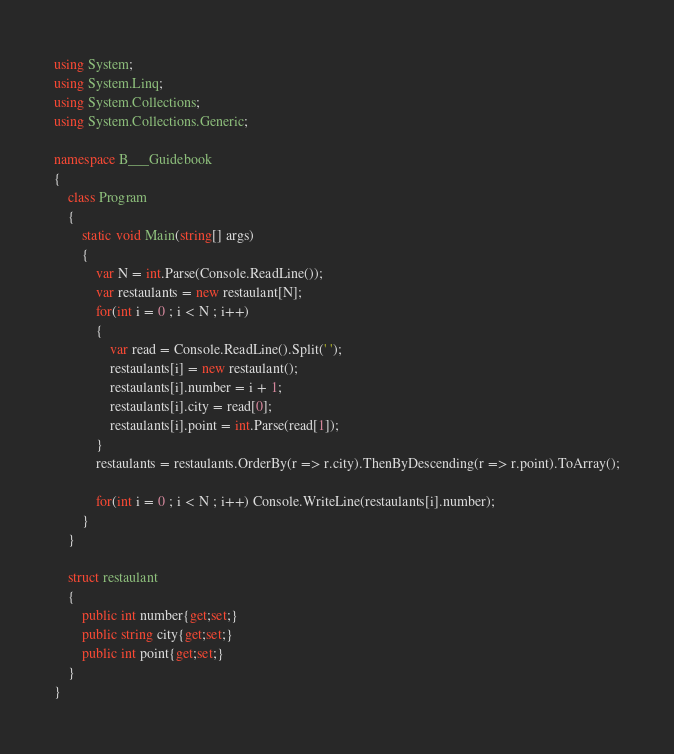Convert code to text. <code><loc_0><loc_0><loc_500><loc_500><_C#_>using System;
using System.Linq;
using System.Collections;
using System.Collections.Generic;

namespace B___Guidebook
{
    class Program
    {
        static void Main(string[] args)
        {
            var N = int.Parse(Console.ReadLine());
            var restaulants = new restaulant[N];
            for(int i = 0 ; i < N ; i++)
            {
                var read = Console.ReadLine().Split(' ');
                restaulants[i] = new restaulant();
                restaulants[i].number = i + 1;
                restaulants[i].city = read[0];
                restaulants[i].point = int.Parse(read[1]);
            }
            restaulants = restaulants.OrderBy(r => r.city).ThenByDescending(r => r.point).ToArray();

            for(int i = 0 ; i < N ; i++) Console.WriteLine(restaulants[i].number);
        }
    }

    struct restaulant
    {
        public int number{get;set;}
        public string city{get;set;}
        public int point{get;set;}
    }
}
</code> 